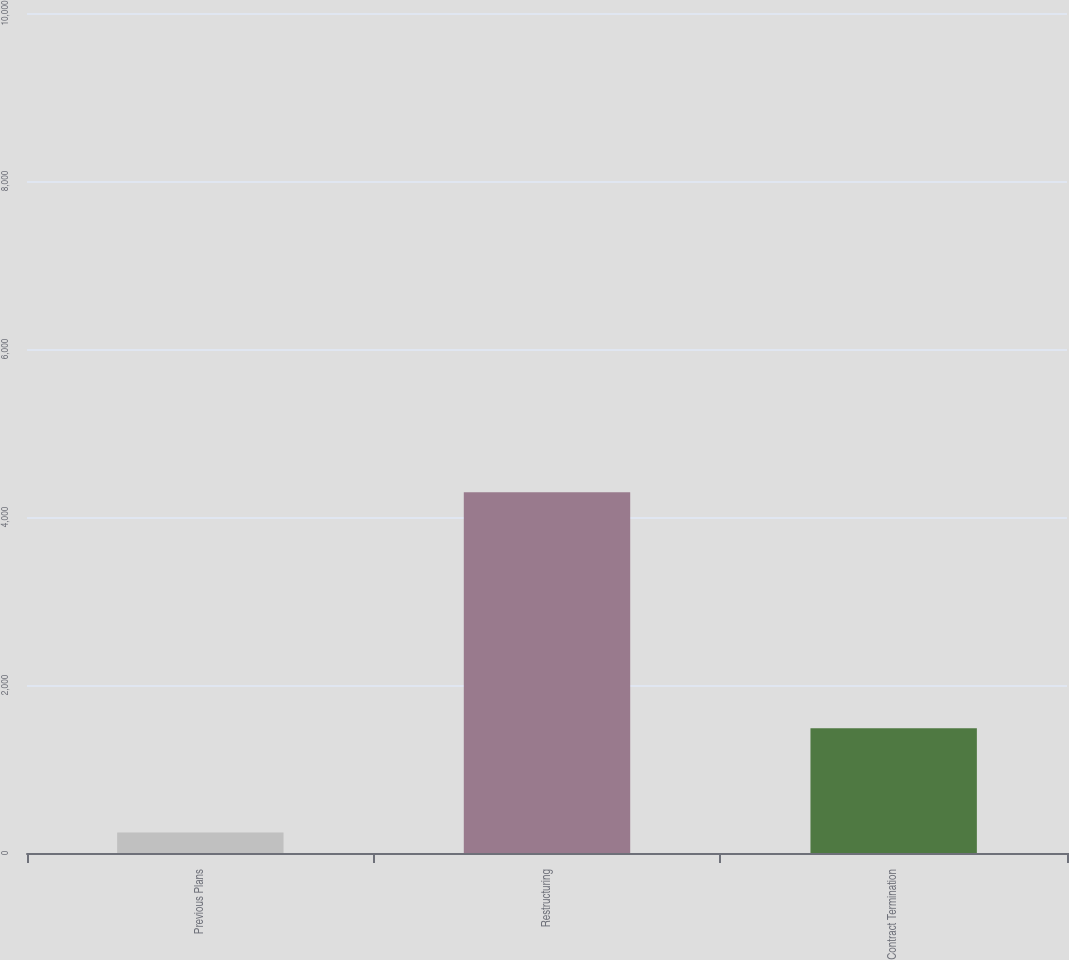Convert chart to OTSL. <chart><loc_0><loc_0><loc_500><loc_500><bar_chart><fcel>Previous Plans<fcel>Restructuring<fcel>Contract Termination<nl><fcel>537<fcel>9406<fcel>3251<nl></chart> 